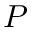Convert formula to latex. <formula><loc_0><loc_0><loc_500><loc_500>P</formula> 